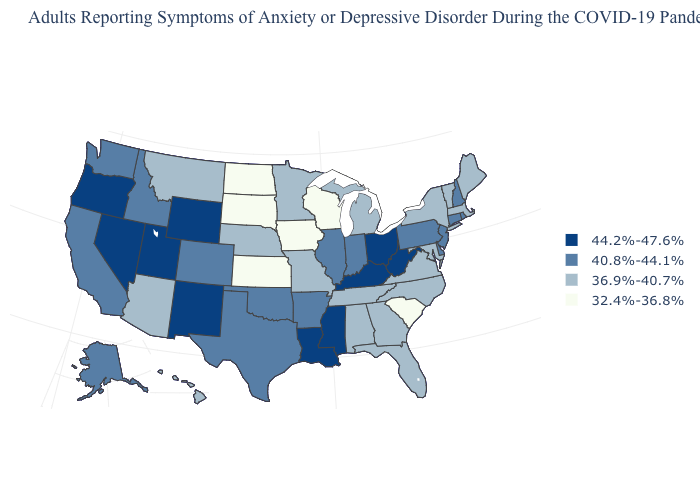Does Maine have the same value as Michigan?
Give a very brief answer. Yes. What is the value of Ohio?
Concise answer only. 44.2%-47.6%. Does Georgia have the same value as New York?
Quick response, please. Yes. Which states hav the highest value in the Northeast?
Short answer required. Connecticut, New Hampshire, New Jersey, Pennsylvania, Rhode Island. Name the states that have a value in the range 36.9%-40.7%?
Write a very short answer. Alabama, Arizona, Florida, Georgia, Hawaii, Maine, Maryland, Massachusetts, Michigan, Minnesota, Missouri, Montana, Nebraska, New York, North Carolina, Tennessee, Vermont, Virginia. What is the value of New Mexico?
Short answer required. 44.2%-47.6%. Name the states that have a value in the range 36.9%-40.7%?
Give a very brief answer. Alabama, Arizona, Florida, Georgia, Hawaii, Maine, Maryland, Massachusetts, Michigan, Minnesota, Missouri, Montana, Nebraska, New York, North Carolina, Tennessee, Vermont, Virginia. What is the highest value in the West ?
Give a very brief answer. 44.2%-47.6%. Which states have the lowest value in the West?
Quick response, please. Arizona, Hawaii, Montana. Does the first symbol in the legend represent the smallest category?
Be succinct. No. Which states have the lowest value in the Northeast?
Keep it brief. Maine, Massachusetts, New York, Vermont. How many symbols are there in the legend?
Concise answer only. 4. Name the states that have a value in the range 44.2%-47.6%?
Short answer required. Kentucky, Louisiana, Mississippi, Nevada, New Mexico, Ohio, Oregon, Utah, West Virginia, Wyoming. Is the legend a continuous bar?
Quick response, please. No. 